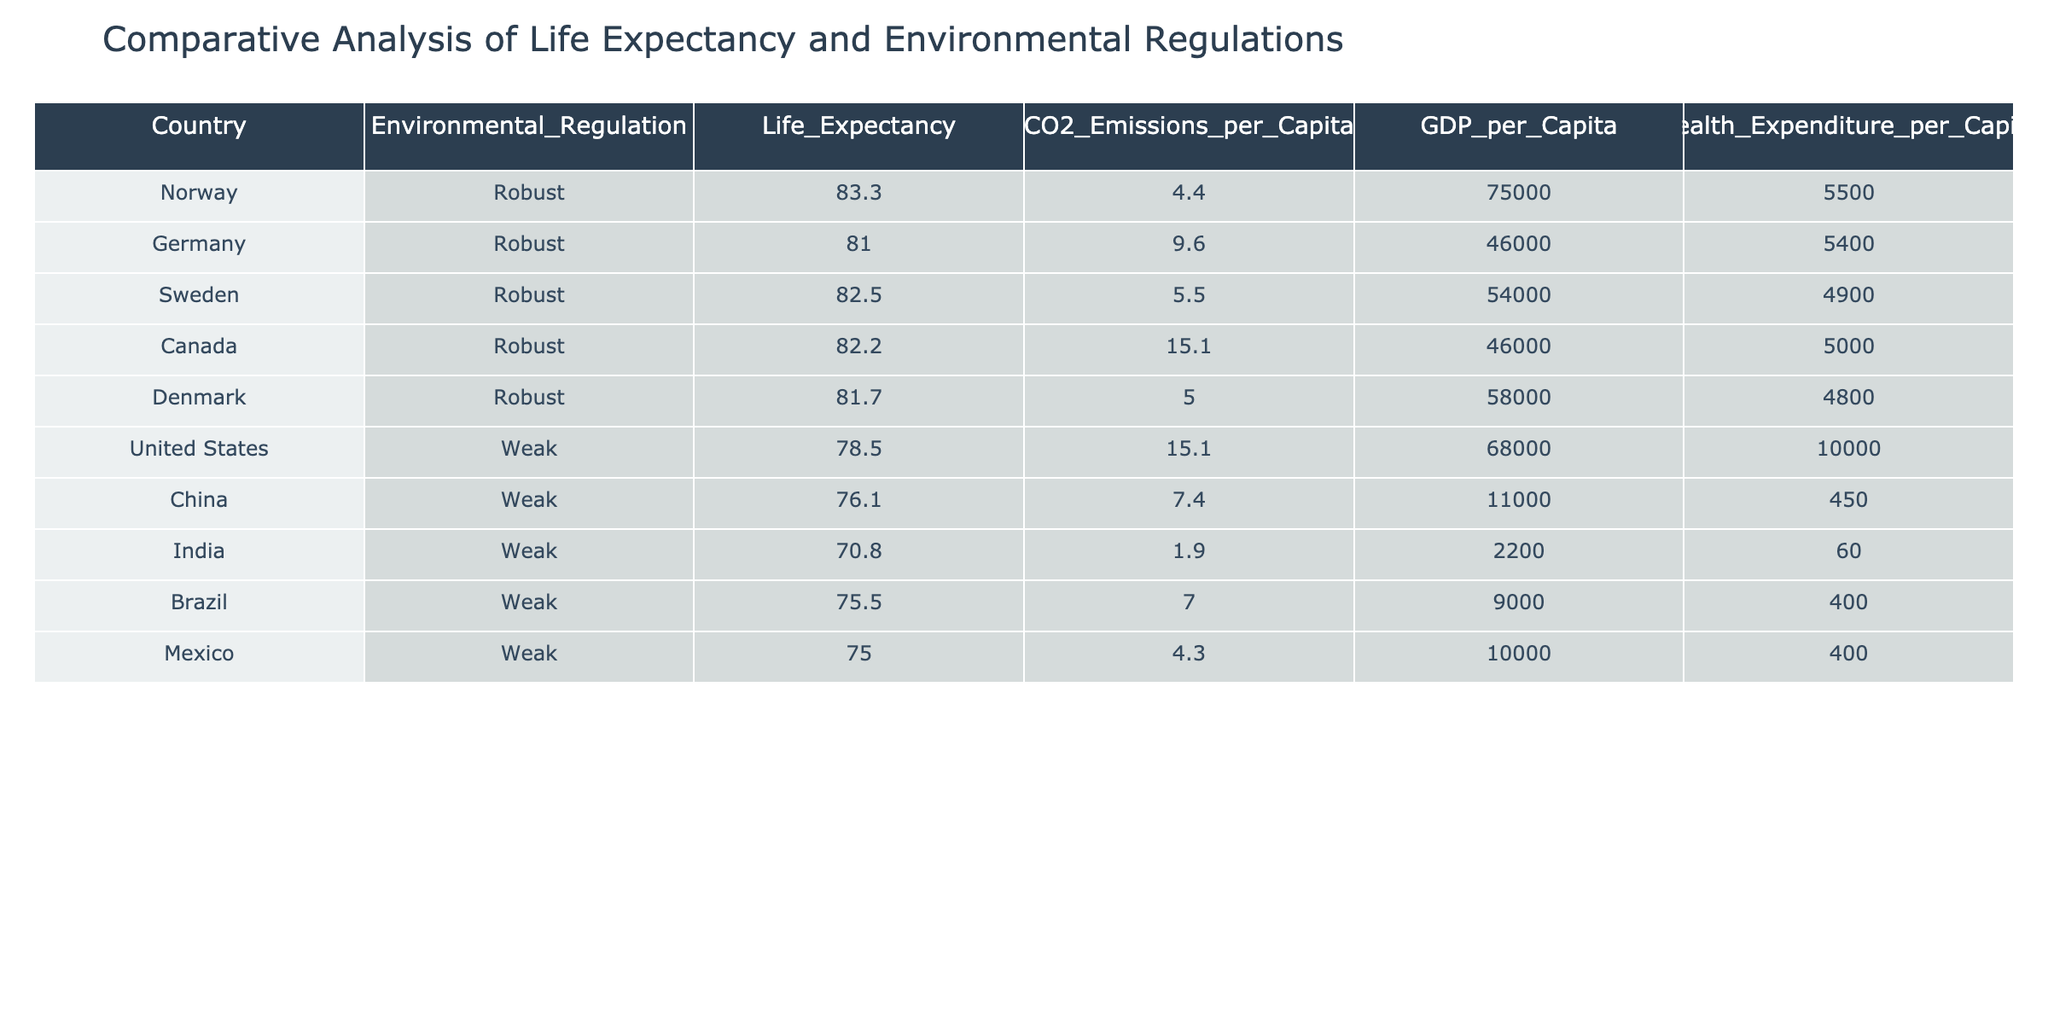What is the life expectancy in Norway? The table shows the life expectancy for each country, and for Norway, it is clearly stated as 83.3 years.
Answer: 83.3 Which country with robust environmental regulations has the highest life expectancy? From the table, we can see that Norway has the highest life expectancy among countries with robust environmental regulations at 83.3 years.
Answer: Norway What is the average life expectancy of countries with weak environmental regulations? To find the average, we sum the life expectancies of countries with weak regulations: 78.5 (United States) + 76.1 (China) + 70.8 (India) + 75.5 (Brazil) + 75.0 (Mexico) = 376.9. There are 5 countries, so the average is 376.9/5 = 75.38 years.
Answer: 75.38 Is the life expectancy in Germany higher than the life expectancy in Brazil? The life expectancy in Germany is 81.0 years, while in Brazil it is 75.5 years. Since 81.0 is greater than 75.5, the statement is true.
Answer: Yes Which country has the lowest CO2 emissions per capita among those with weak environmental regulations? Referring to the table, we see that India has the lowest CO2 emissions per capita at 1.9 tons among the countries listed with weak environmental regulations.
Answer: India How much higher is the life expectancy in Canada compared to that in China? The life expectancy in Canada is 82.2 years, and in China, it is 76.1 years. To find the difference, we subtract: 82.2 - 76.1 = 6.1 years.
Answer: 6.1 Do countries with robust environmental regulations consistently have higher health expenditure per capita compared to those without? By examining the data, we see that while the average health expenditure for countries with robust regulations is higher (approximately 5170), the expenditure for the United States (with weak regulations) is significantly high at 10000. Thus, it is not consistent.
Answer: No What is the life expectancy difference between the United States and Germany? The life expectancy in the United States is 78.5 years, and in Germany, it is 81.0 years. The difference can be calculated as 81.0 - 78.5 = 2.5 years.
Answer: 2.5 Are CO2 emissions per capita in Sweden more than those in Norway? According to the table, Sweden has CO2 emissions of 5.5 tons per capita, while Norway has 4.4 tons. Since 5.5 is greater than 4.4, the answer is yes.
Answer: Yes 